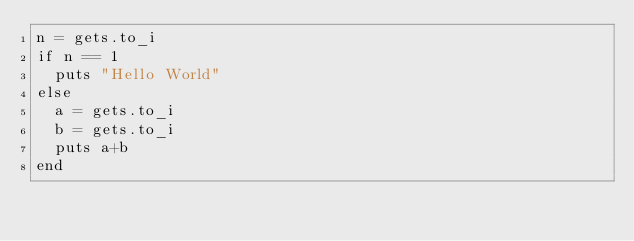<code> <loc_0><loc_0><loc_500><loc_500><_Ruby_>n = gets.to_i
if n == 1
  puts "Hello World"
else
  a = gets.to_i
  b = gets.to_i
  puts a+b
end</code> 